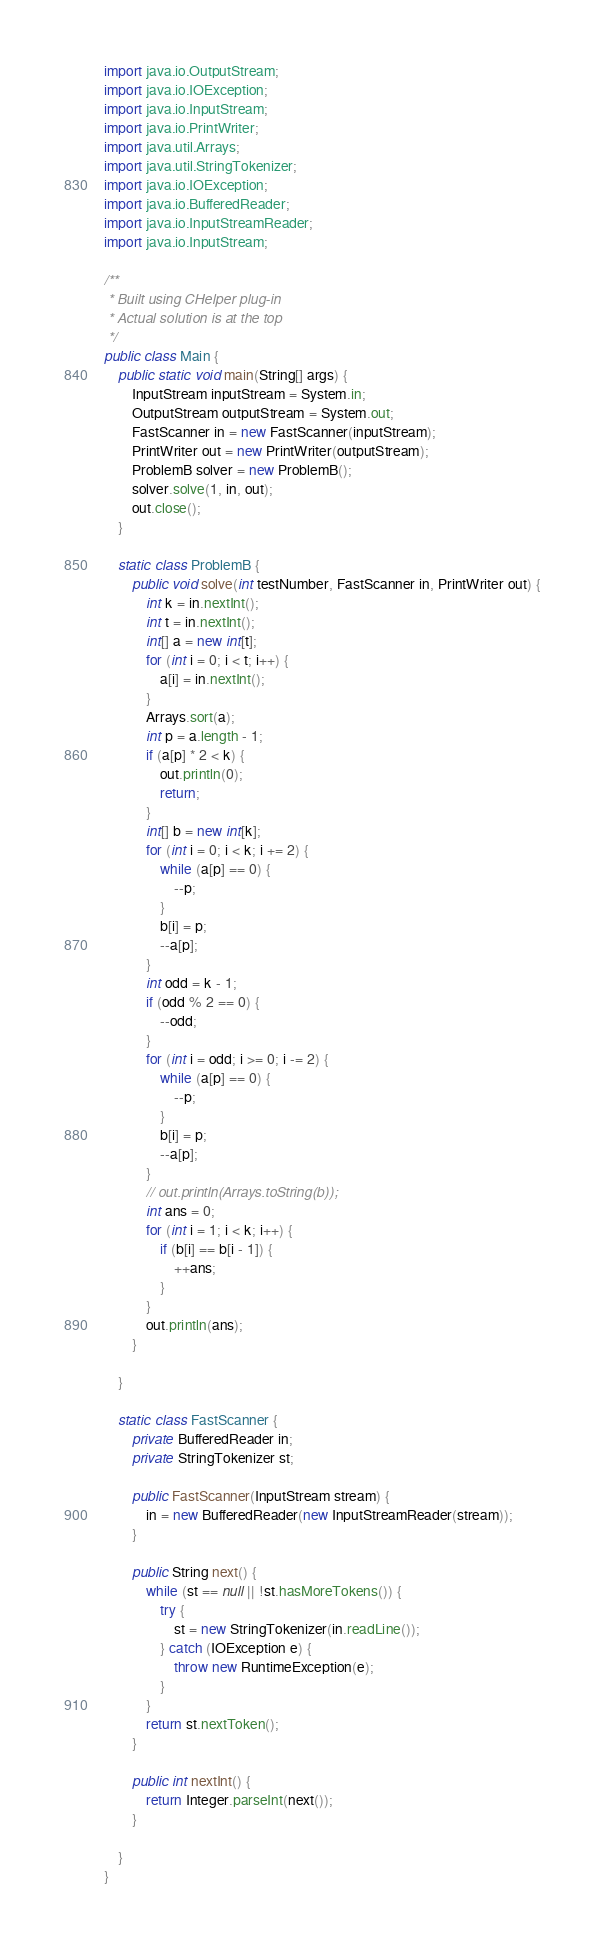<code> <loc_0><loc_0><loc_500><loc_500><_Java_>import java.io.OutputStream;
import java.io.IOException;
import java.io.InputStream;
import java.io.PrintWriter;
import java.util.Arrays;
import java.util.StringTokenizer;
import java.io.IOException;
import java.io.BufferedReader;
import java.io.InputStreamReader;
import java.io.InputStream;

/**
 * Built using CHelper plug-in
 * Actual solution is at the top
 */
public class Main {
	public static void main(String[] args) {
		InputStream inputStream = System.in;
		OutputStream outputStream = System.out;
		FastScanner in = new FastScanner(inputStream);
		PrintWriter out = new PrintWriter(outputStream);
		ProblemB solver = new ProblemB();
		solver.solve(1, in, out);
		out.close();
	}

	static class ProblemB {
		public void solve(int testNumber, FastScanner in, PrintWriter out) {
			int k = in.nextInt();
			int t = in.nextInt();
			int[] a = new int[t];
			for (int i = 0; i < t; i++) {
				a[i] = in.nextInt();
			}
			Arrays.sort(a);
			int p = a.length - 1;
			if (a[p] * 2 < k) {
				out.println(0);
				return;
			}
			int[] b = new int[k];
			for (int i = 0; i < k; i += 2) {
				while (a[p] == 0) {
					--p;
				}
				b[i] = p;
				--a[p];
			}
			int odd = k - 1;
			if (odd % 2 == 0) {
				--odd;
			}
			for (int i = odd; i >= 0; i -= 2) {
				while (a[p] == 0) {
					--p;
				}
				b[i] = p;
				--a[p];
			}
			// out.println(Arrays.toString(b));
			int ans = 0;
			for (int i = 1; i < k; i++) {
				if (b[i] == b[i - 1]) {
					++ans;
				}
			}
			out.println(ans);
		}

	}

	static class FastScanner {
		private BufferedReader in;
		private StringTokenizer st;

		public FastScanner(InputStream stream) {
			in = new BufferedReader(new InputStreamReader(stream));
		}

		public String next() {
			while (st == null || !st.hasMoreTokens()) {
				try {
					st = new StringTokenizer(in.readLine());
				} catch (IOException e) {
					throw new RuntimeException(e);
				}
			}
			return st.nextToken();
		}

		public int nextInt() {
			return Integer.parseInt(next());
		}

	}
}

</code> 